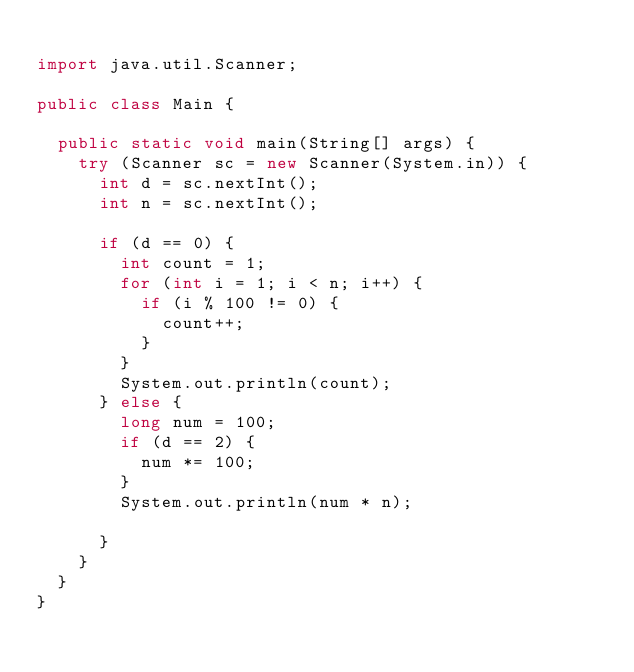Convert code to text. <code><loc_0><loc_0><loc_500><loc_500><_Java_>
import java.util.Scanner;

public class Main {
 
	public static void main(String[] args) {
		try (Scanner sc = new Scanner(System.in)) {
			int d = sc.nextInt();
			int n = sc.nextInt();
			
			if (d == 0) {
				int count = 1;
				for (int i = 1; i < n; i++) {
					if (i % 100 != 0) {
						count++;
					}
				}
				System.out.println(count);
			} else {
				long num = 100;
				if (d == 2) {
					num *= 100;
				}
				System.out.println(num * n);
				
			}
		}
	}
}</code> 